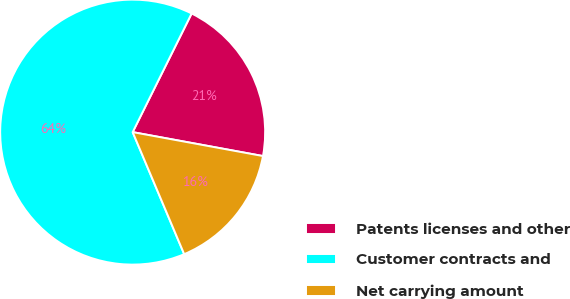Convert chart to OTSL. <chart><loc_0><loc_0><loc_500><loc_500><pie_chart><fcel>Patents licenses and other<fcel>Customer contracts and<fcel>Net carrying amount<nl><fcel>20.55%<fcel>63.7%<fcel>15.75%<nl></chart> 